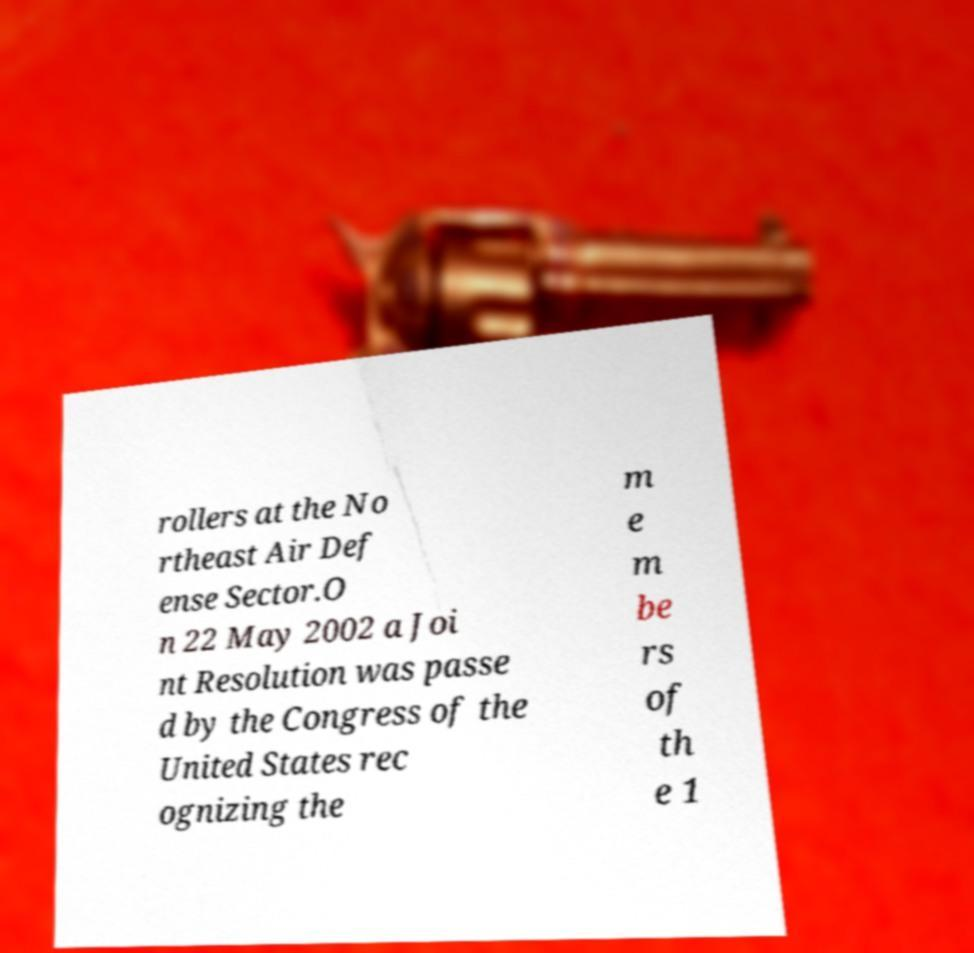Please identify and transcribe the text found in this image. rollers at the No rtheast Air Def ense Sector.O n 22 May 2002 a Joi nt Resolution was passe d by the Congress of the United States rec ognizing the m e m be rs of th e 1 